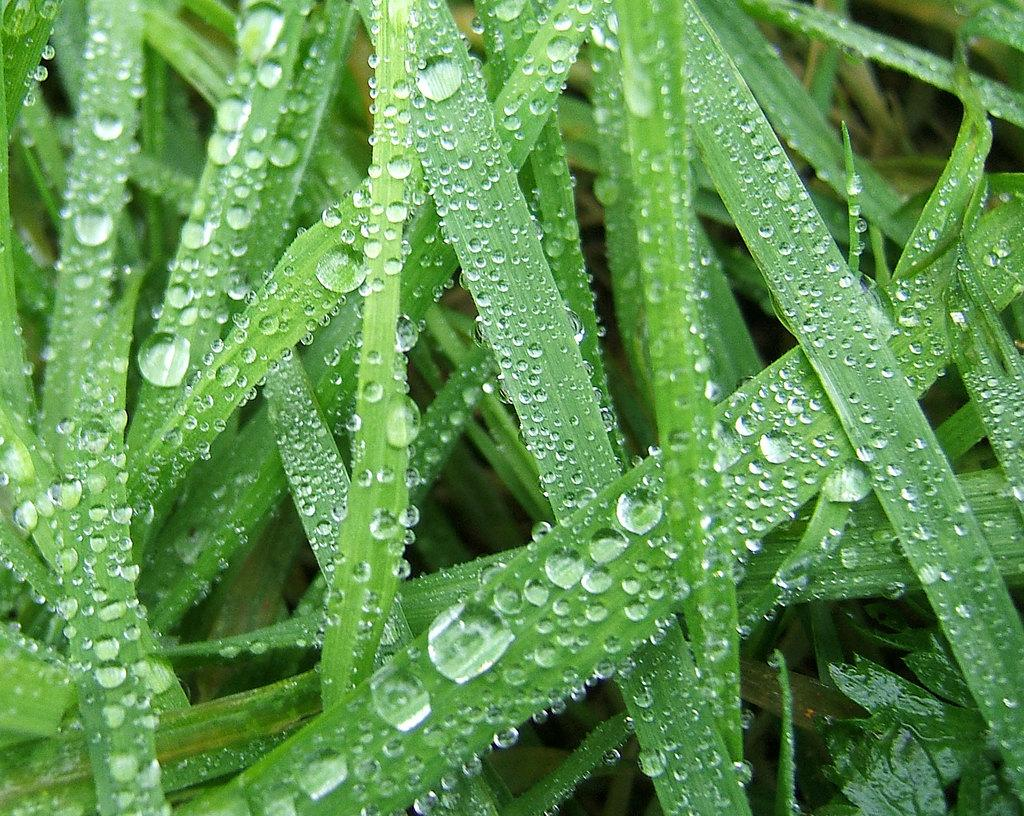What is the condition of the grass in the image? There is dew on the grass in the image. How far away is the library from the grass in the image? There is no library present in the image, so it is not possible to determine the distance between the grass and a library. 